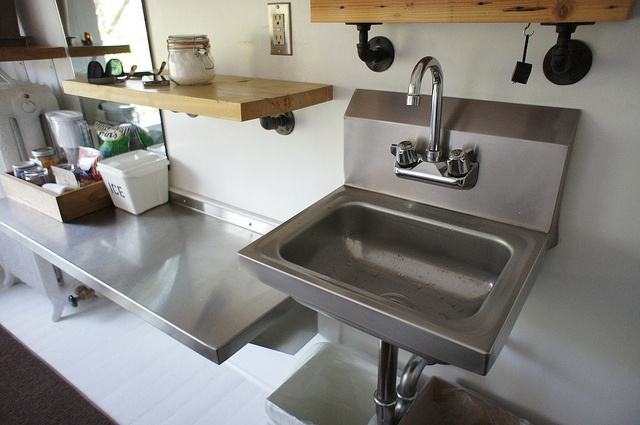Describe the objects in this image and their specific colors. I can see sink in black and gray tones, cell phone in black, white, and gray tones, and cup in black, darkgray, gray, and lavender tones in this image. 